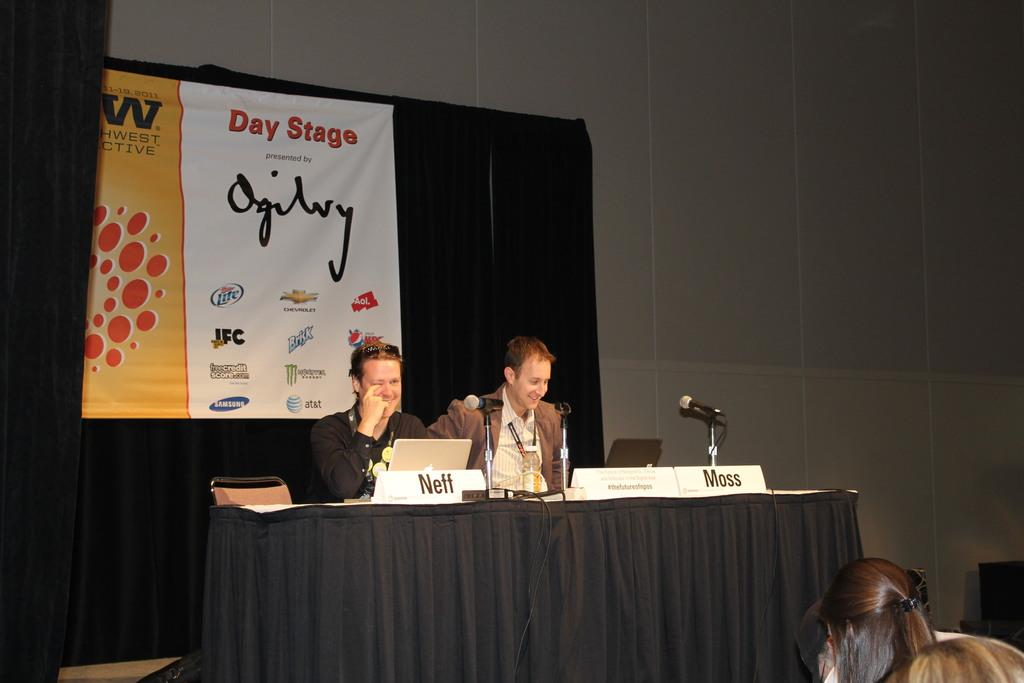How many men are sitting in the image? There are two men sitting on chairs in the image. What are the men sitting in front of? The men are in front of a table. What objects can be seen on the table? There is a microphone and name boards on the table. Are there any people in the image besides the two men? Yes, there are people sitting in front of the men. What is the behavior of the aftermath in the image? There is no reference to an aftermath or any behavior associated with it in the image. 